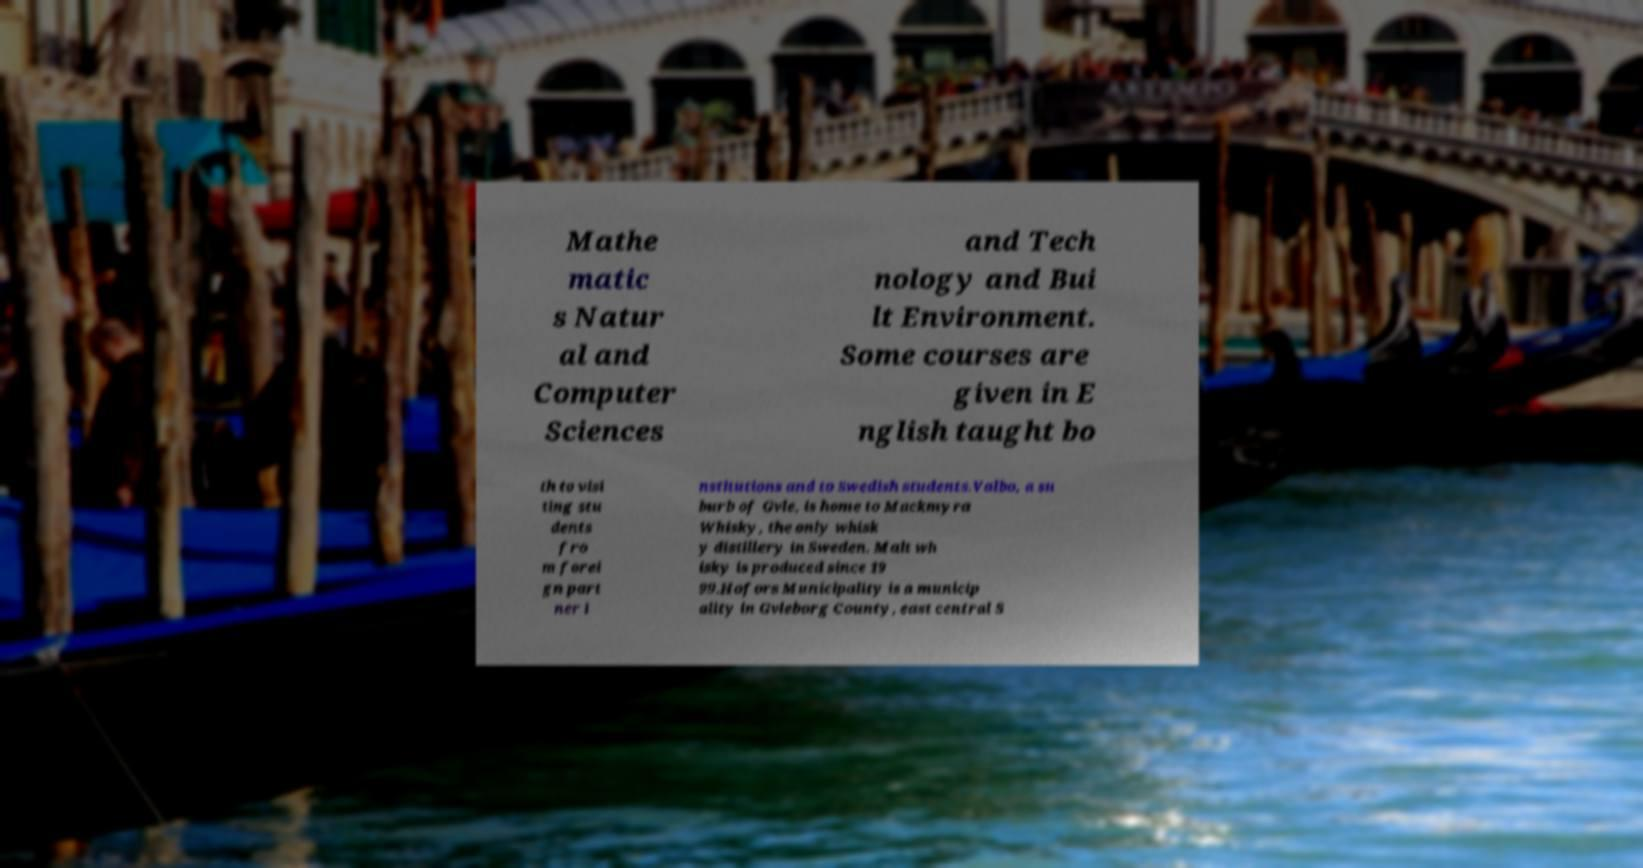There's text embedded in this image that I need extracted. Can you transcribe it verbatim? Mathe matic s Natur al and Computer Sciences and Tech nology and Bui lt Environment. Some courses are given in E nglish taught bo th to visi ting stu dents fro m forei gn part ner i nstitutions and to Swedish students.Valbo, a su burb of Gvle, is home to Mackmyra Whisky, the only whisk y distillery in Sweden. Malt wh isky is produced since 19 99.Hofors Municipality is a municip ality in Gvleborg County, east central S 